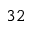Convert formula to latex. <formula><loc_0><loc_0><loc_500><loc_500>3 2</formula> 